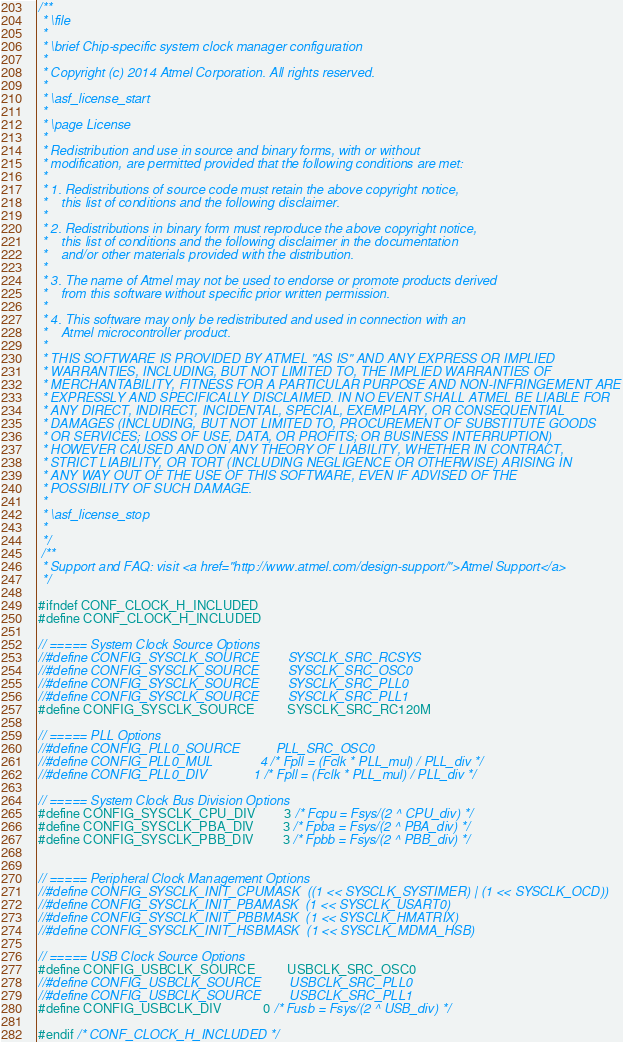<code> <loc_0><loc_0><loc_500><loc_500><_C_>/**
 * \file
 *
 * \brief Chip-specific system clock manager configuration
 *
 * Copyright (c) 2014 Atmel Corporation. All rights reserved.
 * 
 * \asf_license_start
 *
 * \page License
 *
 * Redistribution and use in source and binary forms, with or without
 * modification, are permitted provided that the following conditions are met:
 *
 * 1. Redistributions of source code must retain the above copyright notice,
 *    this list of conditions and the following disclaimer.
 *
 * 2. Redistributions in binary form must reproduce the above copyright notice,
 *    this list of conditions and the following disclaimer in the documentation
 *    and/or other materials provided with the distribution.
 *
 * 3. The name of Atmel may not be used to endorse or promote products derived
 *    from this software without specific prior written permission.
 *
 * 4. This software may only be redistributed and used in connection with an
 *    Atmel microcontroller product.
 *
 * THIS SOFTWARE IS PROVIDED BY ATMEL "AS IS" AND ANY EXPRESS OR IMPLIED
 * WARRANTIES, INCLUDING, BUT NOT LIMITED TO, THE IMPLIED WARRANTIES OF
 * MERCHANTABILITY, FITNESS FOR A PARTICULAR PURPOSE AND NON-INFRINGEMENT ARE
 * EXPRESSLY AND SPECIFICALLY DISCLAIMED. IN NO EVENT SHALL ATMEL BE LIABLE FOR
 * ANY DIRECT, INDIRECT, INCIDENTAL, SPECIAL, EXEMPLARY, OR CONSEQUENTIAL
 * DAMAGES (INCLUDING, BUT NOT LIMITED TO, PROCUREMENT OF SUBSTITUTE GOODS
 * OR SERVICES; LOSS OF USE, DATA, OR PROFITS; OR BUSINESS INTERRUPTION)
 * HOWEVER CAUSED AND ON ANY THEORY OF LIABILITY, WHETHER IN CONTRACT,
 * STRICT LIABILITY, OR TORT (INCLUDING NEGLIGENCE OR OTHERWISE) ARISING IN
 * ANY WAY OUT OF THE USE OF THIS SOFTWARE, EVEN IF ADVISED OF THE
 * POSSIBILITY OF SUCH DAMAGE.
 *
 * \asf_license_stop
 *
 */
 /**
 * Support and FAQ: visit <a href="http://www.atmel.com/design-support/">Atmel Support</a>
 */

#ifndef CONF_CLOCK_H_INCLUDED
#define CONF_CLOCK_H_INCLUDED

// ===== System Clock Source Options
//#define CONFIG_SYSCLK_SOURCE        SYSCLK_SRC_RCSYS
//#define CONFIG_SYSCLK_SOURCE        SYSCLK_SRC_OSC0
//#define CONFIG_SYSCLK_SOURCE        SYSCLK_SRC_PLL0
//#define CONFIG_SYSCLK_SOURCE        SYSCLK_SRC_PLL1
#define CONFIG_SYSCLK_SOURCE          SYSCLK_SRC_RC120M

// ===== PLL Options
//#define CONFIG_PLL0_SOURCE          PLL_SRC_OSC0
//#define CONFIG_PLL0_MUL             4 /* Fpll = (Fclk * PLL_mul) / PLL_div */
//#define CONFIG_PLL0_DIV             1 /* Fpll = (Fclk * PLL_mul) / PLL_div */

// ===== System Clock Bus Division Options
#define CONFIG_SYSCLK_CPU_DIV         3 /* Fcpu = Fsys/(2 ^ CPU_div) */
#define CONFIG_SYSCLK_PBA_DIV         3 /* Fpba = Fsys/(2 ^ PBA_div) */
#define CONFIG_SYSCLK_PBB_DIV         3 /* Fpbb = Fsys/(2 ^ PBB_div) */


// ===== Peripheral Clock Management Options
//#define CONFIG_SYSCLK_INIT_CPUMASK  ((1 << SYSCLK_SYSTIMER) | (1 << SYSCLK_OCD))
//#define CONFIG_SYSCLK_INIT_PBAMASK  (1 << SYSCLK_USART0)
//#define CONFIG_SYSCLK_INIT_PBBMASK  (1 << SYSCLK_HMATRIX)
//#define CONFIG_SYSCLK_INIT_HSBMASK  (1 << SYSCLK_MDMA_HSB)

// ===== USB Clock Source Options
#define CONFIG_USBCLK_SOURCE          USBCLK_SRC_OSC0
//#define CONFIG_USBCLK_SOURCE        USBCLK_SRC_PLL0
//#define CONFIG_USBCLK_SOURCE        USBCLK_SRC_PLL1
#define CONFIG_USBCLK_DIV             0 /* Fusb = Fsys/(2 ^ USB_div) */

#endif /* CONF_CLOCK_H_INCLUDED */
</code> 